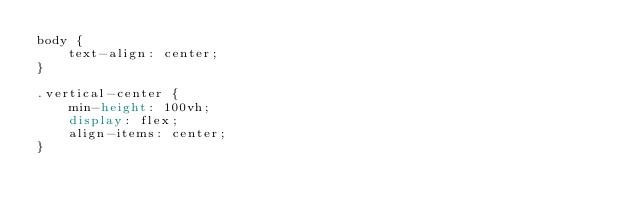Convert code to text. <code><loc_0><loc_0><loc_500><loc_500><_CSS_>body {
    text-align: center;
}

.vertical-center {
    min-height: 100vh;
    display: flex;
    align-items: center;
}

</code> 